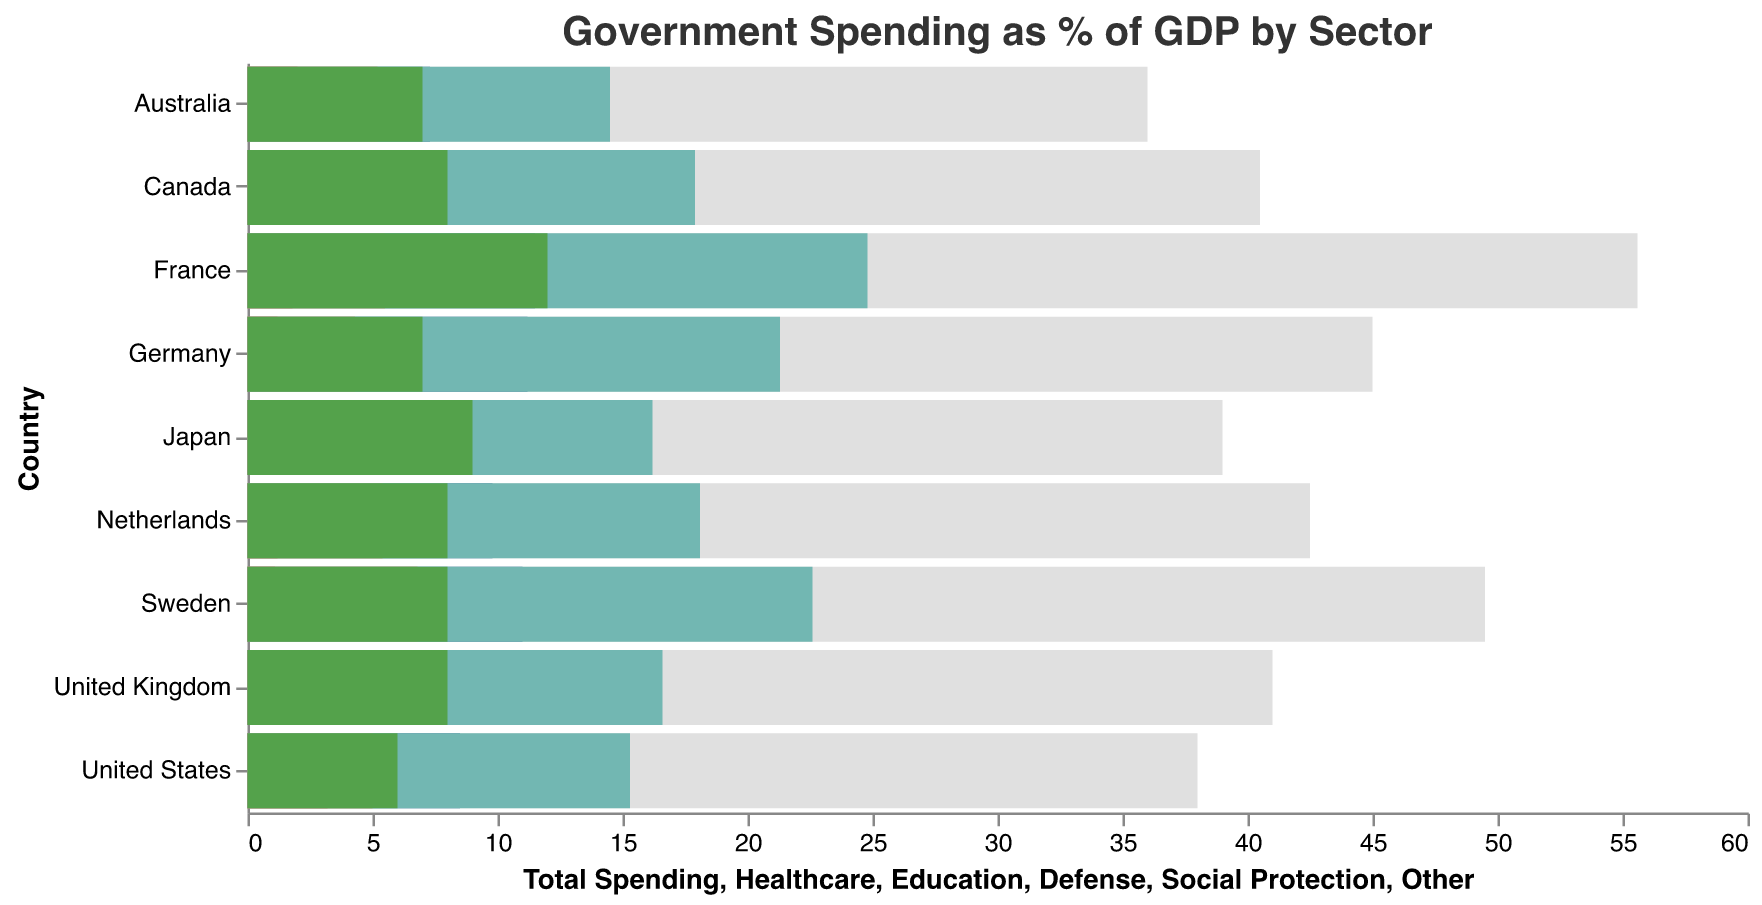What's the title of the chart? The title can be found at the top of the chart. It provides context and subject matter of the visualized data.
Answer: "Government Spending as % of GDP by Sector" Which country has the highest total spending as a percentage of GDP? Look for the tallest bar in the "Total Spending" dimension across all countries.
Answer: France What is the total government spending of Japan as a percentage of GDP? Find the bar associated with Japan and note its length corresponding to total spending.
Answer: 39% Which country spends the most on healthcare? Check the healthcare bars and identify the highest one.
Answer: France Compare the healthcare spending between the United States and Germany. Find the healthcare bars for both countries and compare their lengths.
Answer: United States: 8.5%, Germany: 11.2% What's the difference in social protection spending between Sweden and Japan? Subtract the social protection percentage of Japan from Sweden's.
Answer: 22.6% - 16.2% = 6.4% For which sector does France allocate the highest percentage of its GDP? Look at the breakdown of sectors for France and identify the largest bar.
Answer: Social Protection Rank the countries by their total spending from highest to lowest. Arrange the countries based on the length of the total spending bars in descending order.
Answer: France, Sweden, Germany, Netherlands, United Kingdom, Canada, Japan, United States, Australia How does the defense spending of Australia compare to that of the United Kingdom? Check the defense spending bars for both countries and compare their lengths.
Answer: Australia: 2%, United Kingdom: 2% What percentage of GDP does the Netherlands allocate to social protection? Find the social protection bar for the Netherlands and note its length.
Answer: 18.1% 